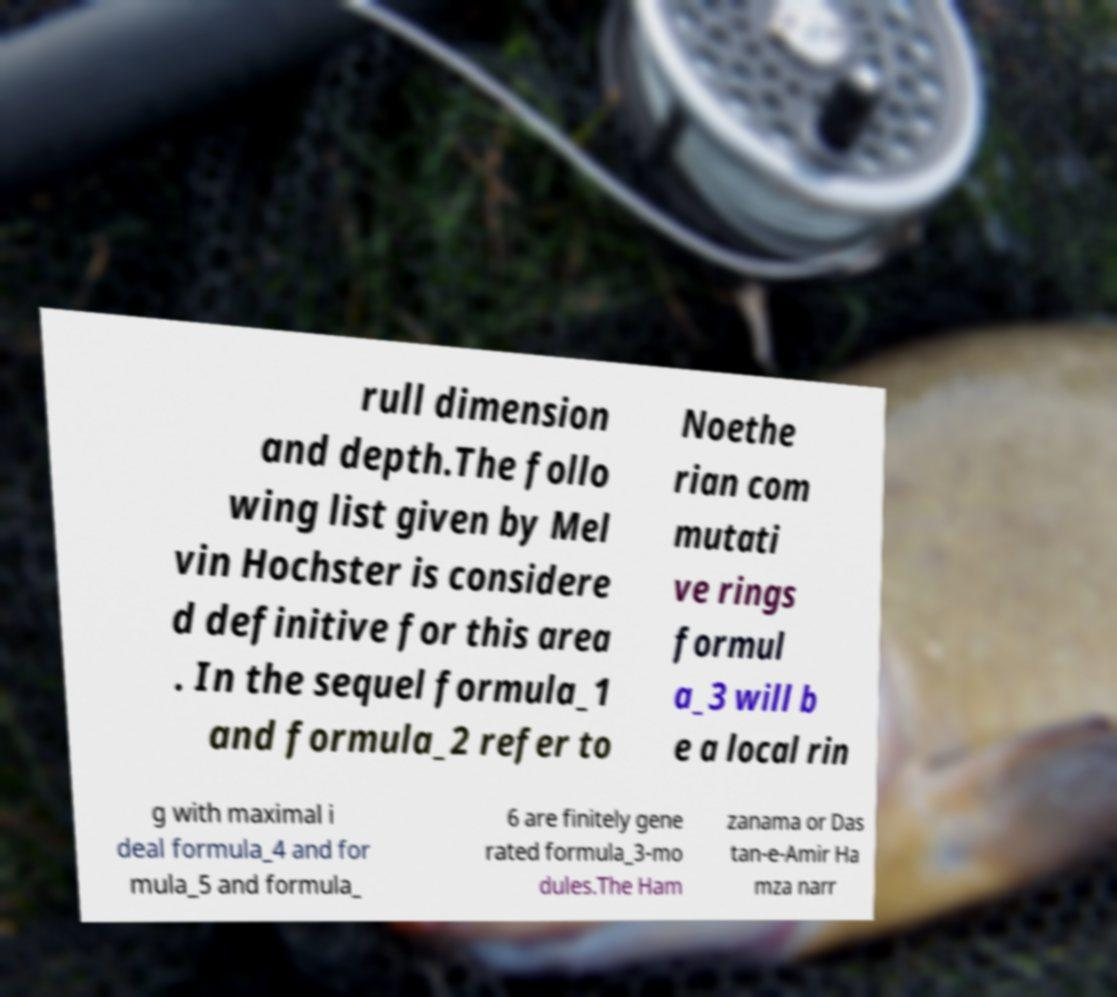Could you assist in decoding the text presented in this image and type it out clearly? rull dimension and depth.The follo wing list given by Mel vin Hochster is considere d definitive for this area . In the sequel formula_1 and formula_2 refer to Noethe rian com mutati ve rings formul a_3 will b e a local rin g with maximal i deal formula_4 and for mula_5 and formula_ 6 are finitely gene rated formula_3-mo dules.The Ham zanama or Das tan-e-Amir Ha mza narr 